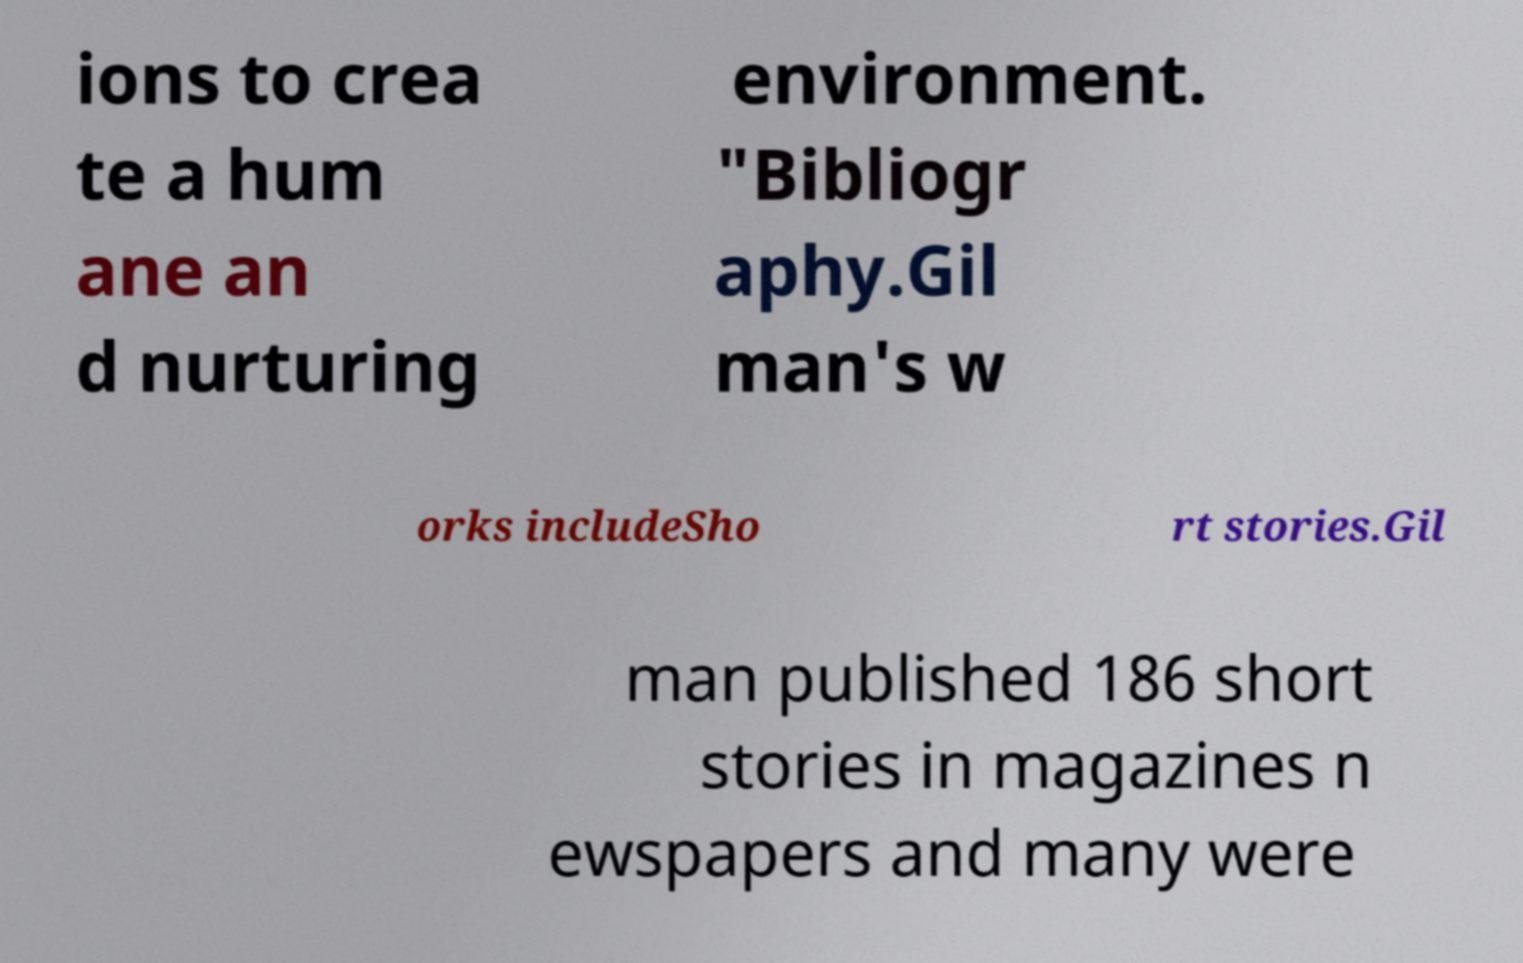I need the written content from this picture converted into text. Can you do that? ions to crea te a hum ane an d nurturing environment. "Bibliogr aphy.Gil man's w orks includeSho rt stories.Gil man published 186 short stories in magazines n ewspapers and many were 